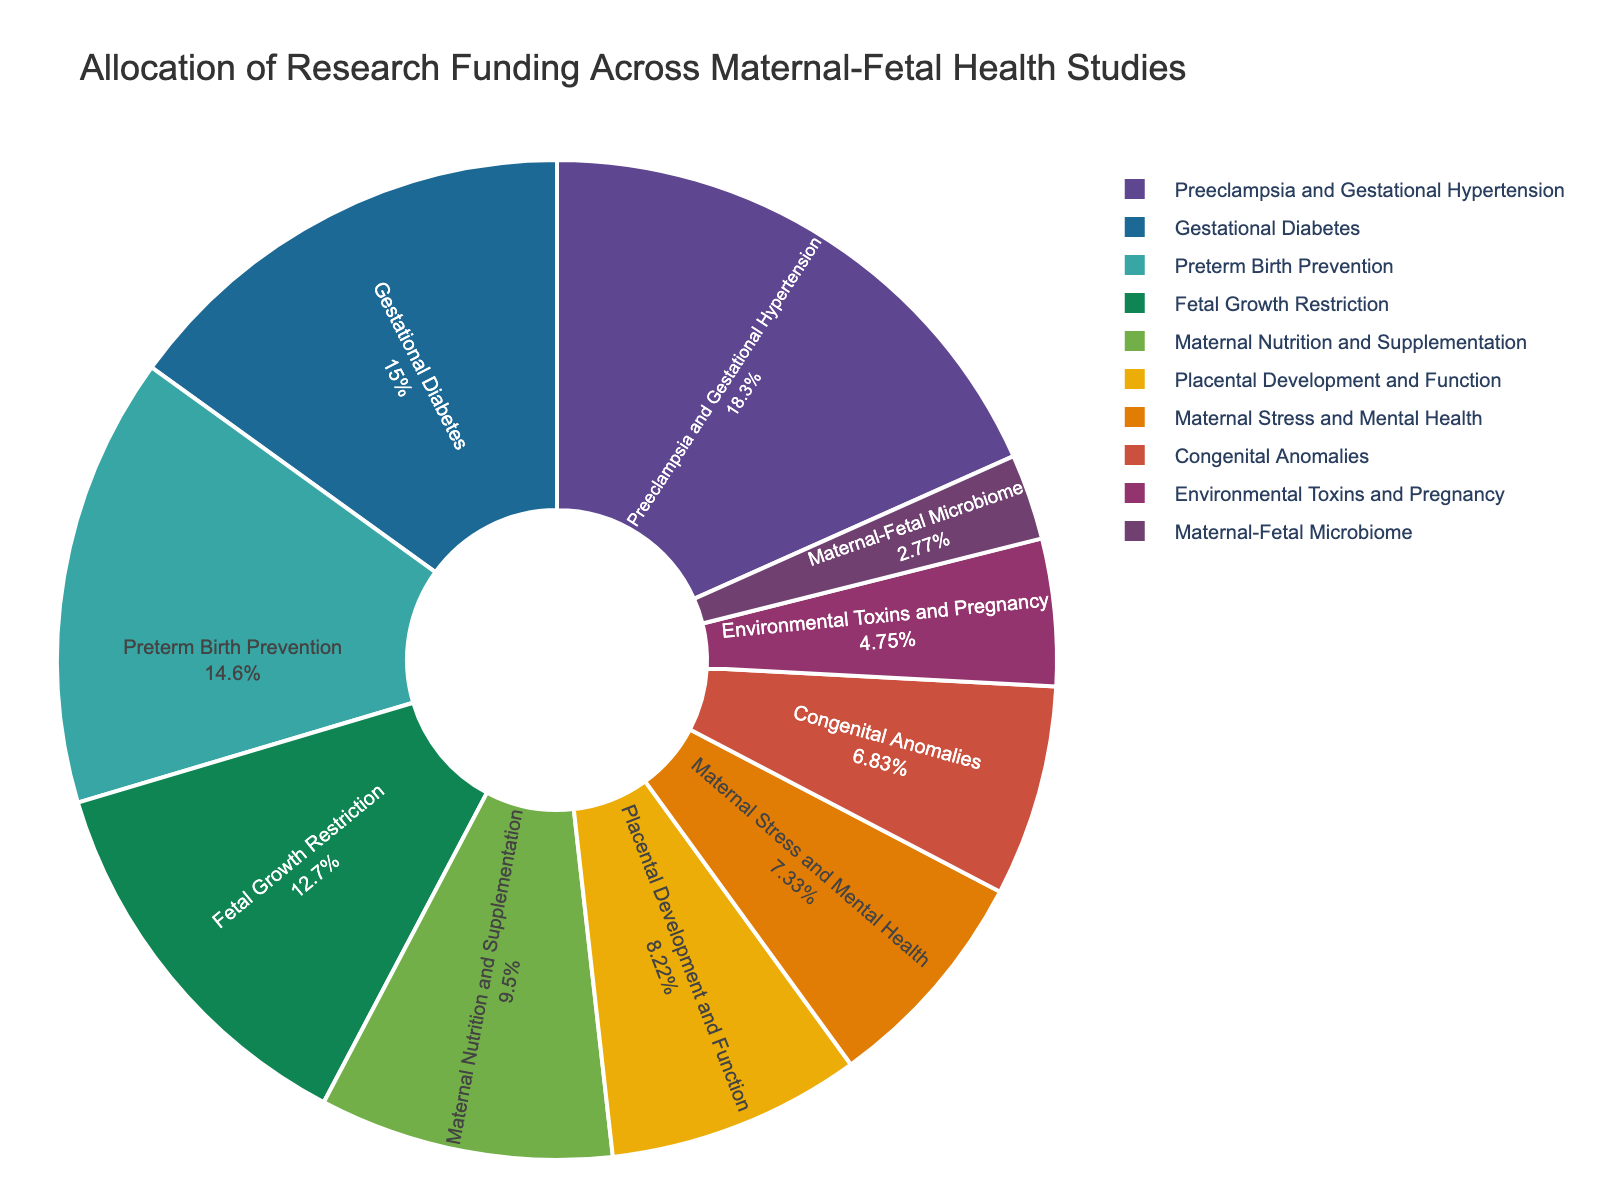What is the research area with the highest funding allocation? By visual inspection, the largest segment of the pie chart represents the research area with the highest funding.
Answer: Preeclampsia and Gestational Hypertension Which research area has the second-lowest funding allocation? Identify the second smallest segment of the pie chart, which depicts the area with the second-lowest funding.
Answer: Maternal-Fetal Microbiome How much more funding does Preeclampsia and Gestational Hypertension receive compared to Placental Development and Function? Subtract the funding percentage of Placental Development and Function from Preeclampsia and Gestational Hypertension: 18.5% - 8.3% = 10.2%
Answer: 10.2% What is the total funding allocation for Fetal Growth Restriction and Preterm Birth Prevention combined? Add the percentages of Fetal Growth Restriction and Preterm Birth Prevention: 12.8% + 14.7% = 27.5%
Answer: 27.5% Which research areas receive less than 10% of the funding allocation? Identify all segments of the pie chart that represent less than 10% funding each: Maternal Nutrition and Supplementation, Placental Development and Function, Maternal Stress and Mental Health, Congenital Anomalies, Environmental Toxins and Pregnancy, Maternal-Fetal Microbiome
Answer: Six research areas Is the funding allocation for Preterm Birth Prevention greater than for Gestational Diabetes? Compare the sizes of the segments representing Preterm Birth Prevention and Gestational Diabetes: 14.7% vs. 15.2%
Answer: No What percentage of the funding is dedicated to research areas related to maternal health (specifically Maternal Nutrition and Supplementation, and Maternal Stress and Mental Health)? Sum the percentages of Maternal Nutrition and Supplementation, and Maternal Stress and Mental Health: 9.6% + 7.4% = 17%
Answer: 17% Which research area takes up the smallest segment of the pie chart? Visually identify the smallest segment in the pie chart.
Answer: Maternal-Fetal Microbiome Between Congenital Anomalies and Environmental Toxins and Pregnancy, which area has a higher allocation? Compare the segments representing Congenital Anomalies and Environmental Toxins and Pregnancy: 6.9% vs. 4.8%
Answer: Congenital Anomalies 